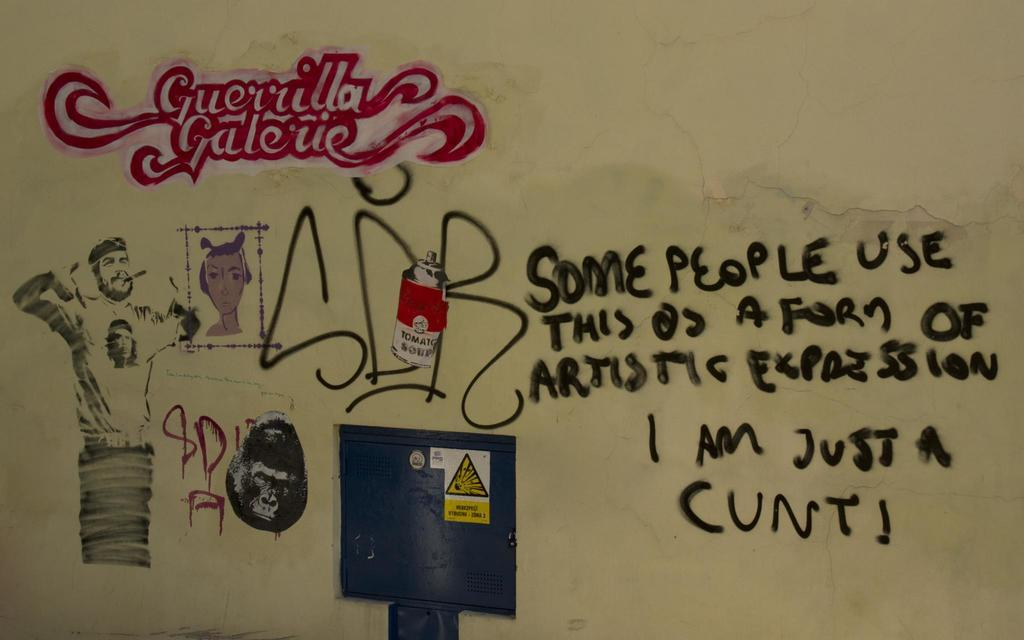What can be seen on the wall in the image? There are drawings, texts, a picture of a man, and a picture of an animal on the wall in the image. Can you describe the contents of the drawings and texts on the wall? Unfortunately, the specific contents of the drawings and texts cannot be determined from the image. What else is visible in the image besides the wall? There is a locker door visible in the image. What type of brick is used to build the wall in the image? There is no brick visible in the image; the wall appears to be made of a different material. 